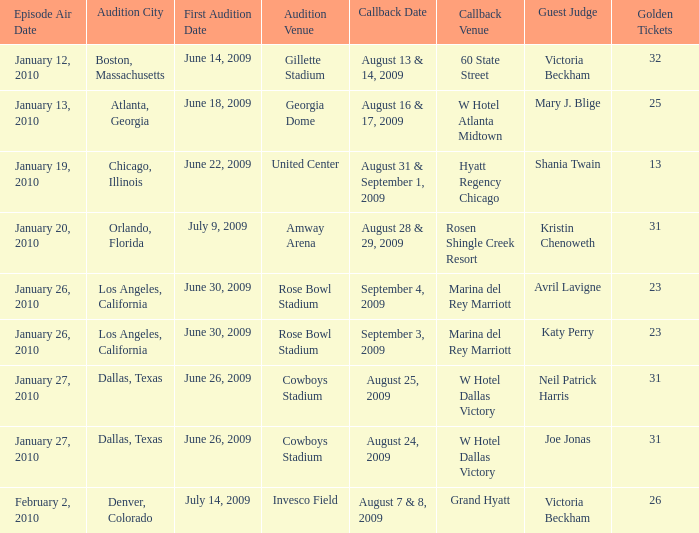Name the audition city for hyatt regency chicago Chicago, Illinois. 